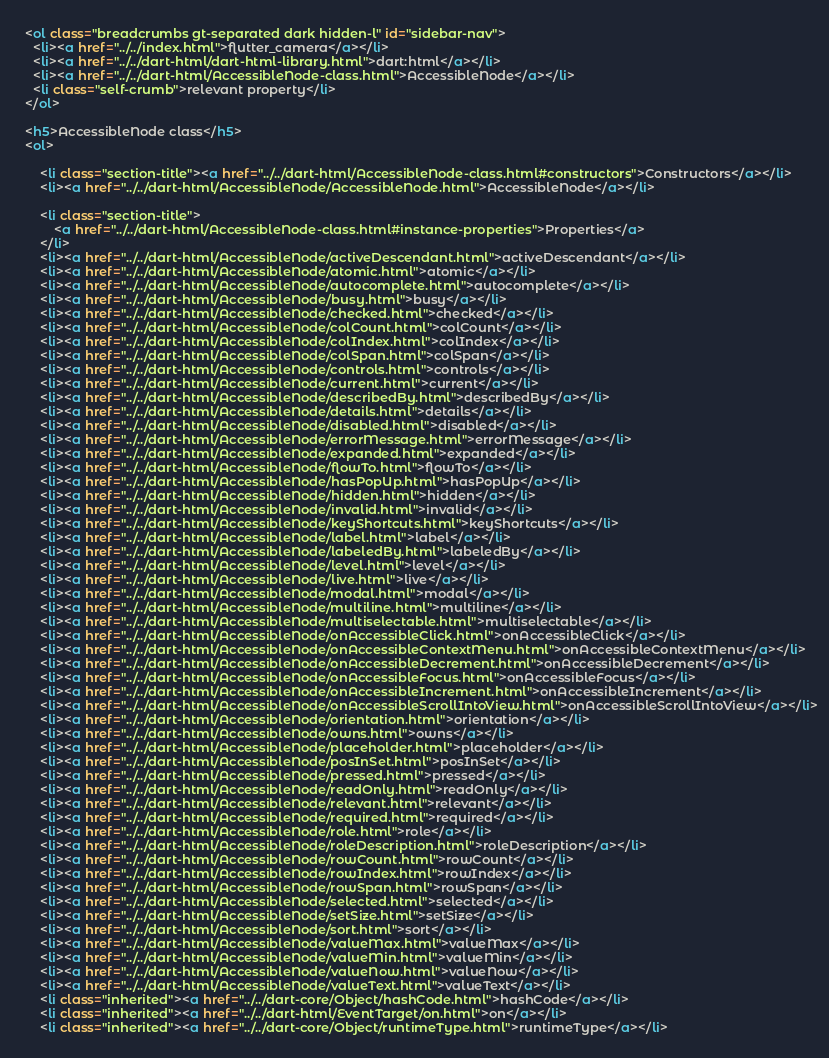Convert code to text. <code><loc_0><loc_0><loc_500><loc_500><_HTML_>    
    <ol class="breadcrumbs gt-separated dark hidden-l" id="sidebar-nav">
      <li><a href="../../index.html">flutter_camera</a></li>
      <li><a href="../../dart-html/dart-html-library.html">dart:html</a></li>
      <li><a href="../../dart-html/AccessibleNode-class.html">AccessibleNode</a></li>
      <li class="self-crumb">relevant property</li>
    </ol>
    
    <h5>AccessibleNode class</h5>
    <ol>
    
        <li class="section-title"><a href="../../dart-html/AccessibleNode-class.html#constructors">Constructors</a></li>
        <li><a href="../../dart-html/AccessibleNode/AccessibleNode.html">AccessibleNode</a></li>
    
        <li class="section-title">
            <a href="../../dart-html/AccessibleNode-class.html#instance-properties">Properties</a>
        </li>
        <li><a href="../../dart-html/AccessibleNode/activeDescendant.html">activeDescendant</a></li>
        <li><a href="../../dart-html/AccessibleNode/atomic.html">atomic</a></li>
        <li><a href="../../dart-html/AccessibleNode/autocomplete.html">autocomplete</a></li>
        <li><a href="../../dart-html/AccessibleNode/busy.html">busy</a></li>
        <li><a href="../../dart-html/AccessibleNode/checked.html">checked</a></li>
        <li><a href="../../dart-html/AccessibleNode/colCount.html">colCount</a></li>
        <li><a href="../../dart-html/AccessibleNode/colIndex.html">colIndex</a></li>
        <li><a href="../../dart-html/AccessibleNode/colSpan.html">colSpan</a></li>
        <li><a href="../../dart-html/AccessibleNode/controls.html">controls</a></li>
        <li><a href="../../dart-html/AccessibleNode/current.html">current</a></li>
        <li><a href="../../dart-html/AccessibleNode/describedBy.html">describedBy</a></li>
        <li><a href="../../dart-html/AccessibleNode/details.html">details</a></li>
        <li><a href="../../dart-html/AccessibleNode/disabled.html">disabled</a></li>
        <li><a href="../../dart-html/AccessibleNode/errorMessage.html">errorMessage</a></li>
        <li><a href="../../dart-html/AccessibleNode/expanded.html">expanded</a></li>
        <li><a href="../../dart-html/AccessibleNode/flowTo.html">flowTo</a></li>
        <li><a href="../../dart-html/AccessibleNode/hasPopUp.html">hasPopUp</a></li>
        <li><a href="../../dart-html/AccessibleNode/hidden.html">hidden</a></li>
        <li><a href="../../dart-html/AccessibleNode/invalid.html">invalid</a></li>
        <li><a href="../../dart-html/AccessibleNode/keyShortcuts.html">keyShortcuts</a></li>
        <li><a href="../../dart-html/AccessibleNode/label.html">label</a></li>
        <li><a href="../../dart-html/AccessibleNode/labeledBy.html">labeledBy</a></li>
        <li><a href="../../dart-html/AccessibleNode/level.html">level</a></li>
        <li><a href="../../dart-html/AccessibleNode/live.html">live</a></li>
        <li><a href="../../dart-html/AccessibleNode/modal.html">modal</a></li>
        <li><a href="../../dart-html/AccessibleNode/multiline.html">multiline</a></li>
        <li><a href="../../dart-html/AccessibleNode/multiselectable.html">multiselectable</a></li>
        <li><a href="../../dart-html/AccessibleNode/onAccessibleClick.html">onAccessibleClick</a></li>
        <li><a href="../../dart-html/AccessibleNode/onAccessibleContextMenu.html">onAccessibleContextMenu</a></li>
        <li><a href="../../dart-html/AccessibleNode/onAccessibleDecrement.html">onAccessibleDecrement</a></li>
        <li><a href="../../dart-html/AccessibleNode/onAccessibleFocus.html">onAccessibleFocus</a></li>
        <li><a href="../../dart-html/AccessibleNode/onAccessibleIncrement.html">onAccessibleIncrement</a></li>
        <li><a href="../../dart-html/AccessibleNode/onAccessibleScrollIntoView.html">onAccessibleScrollIntoView</a></li>
        <li><a href="../../dart-html/AccessibleNode/orientation.html">orientation</a></li>
        <li><a href="../../dart-html/AccessibleNode/owns.html">owns</a></li>
        <li><a href="../../dart-html/AccessibleNode/placeholder.html">placeholder</a></li>
        <li><a href="../../dart-html/AccessibleNode/posInSet.html">posInSet</a></li>
        <li><a href="../../dart-html/AccessibleNode/pressed.html">pressed</a></li>
        <li><a href="../../dart-html/AccessibleNode/readOnly.html">readOnly</a></li>
        <li><a href="../../dart-html/AccessibleNode/relevant.html">relevant</a></li>
        <li><a href="../../dart-html/AccessibleNode/required.html">required</a></li>
        <li><a href="../../dart-html/AccessibleNode/role.html">role</a></li>
        <li><a href="../../dart-html/AccessibleNode/roleDescription.html">roleDescription</a></li>
        <li><a href="../../dart-html/AccessibleNode/rowCount.html">rowCount</a></li>
        <li><a href="../../dart-html/AccessibleNode/rowIndex.html">rowIndex</a></li>
        <li><a href="../../dart-html/AccessibleNode/rowSpan.html">rowSpan</a></li>
        <li><a href="../../dart-html/AccessibleNode/selected.html">selected</a></li>
        <li><a href="../../dart-html/AccessibleNode/setSize.html">setSize</a></li>
        <li><a href="../../dart-html/AccessibleNode/sort.html">sort</a></li>
        <li><a href="../../dart-html/AccessibleNode/valueMax.html">valueMax</a></li>
        <li><a href="../../dart-html/AccessibleNode/valueMin.html">valueMin</a></li>
        <li><a href="../../dart-html/AccessibleNode/valueNow.html">valueNow</a></li>
        <li><a href="../../dart-html/AccessibleNode/valueText.html">valueText</a></li>
        <li class="inherited"><a href="../../dart-core/Object/hashCode.html">hashCode</a></li>
        <li class="inherited"><a href="../../dart-html/EventTarget/on.html">on</a></li>
        <li class="inherited"><a href="../../dart-core/Object/runtimeType.html">runtimeType</a></li>
    </code> 